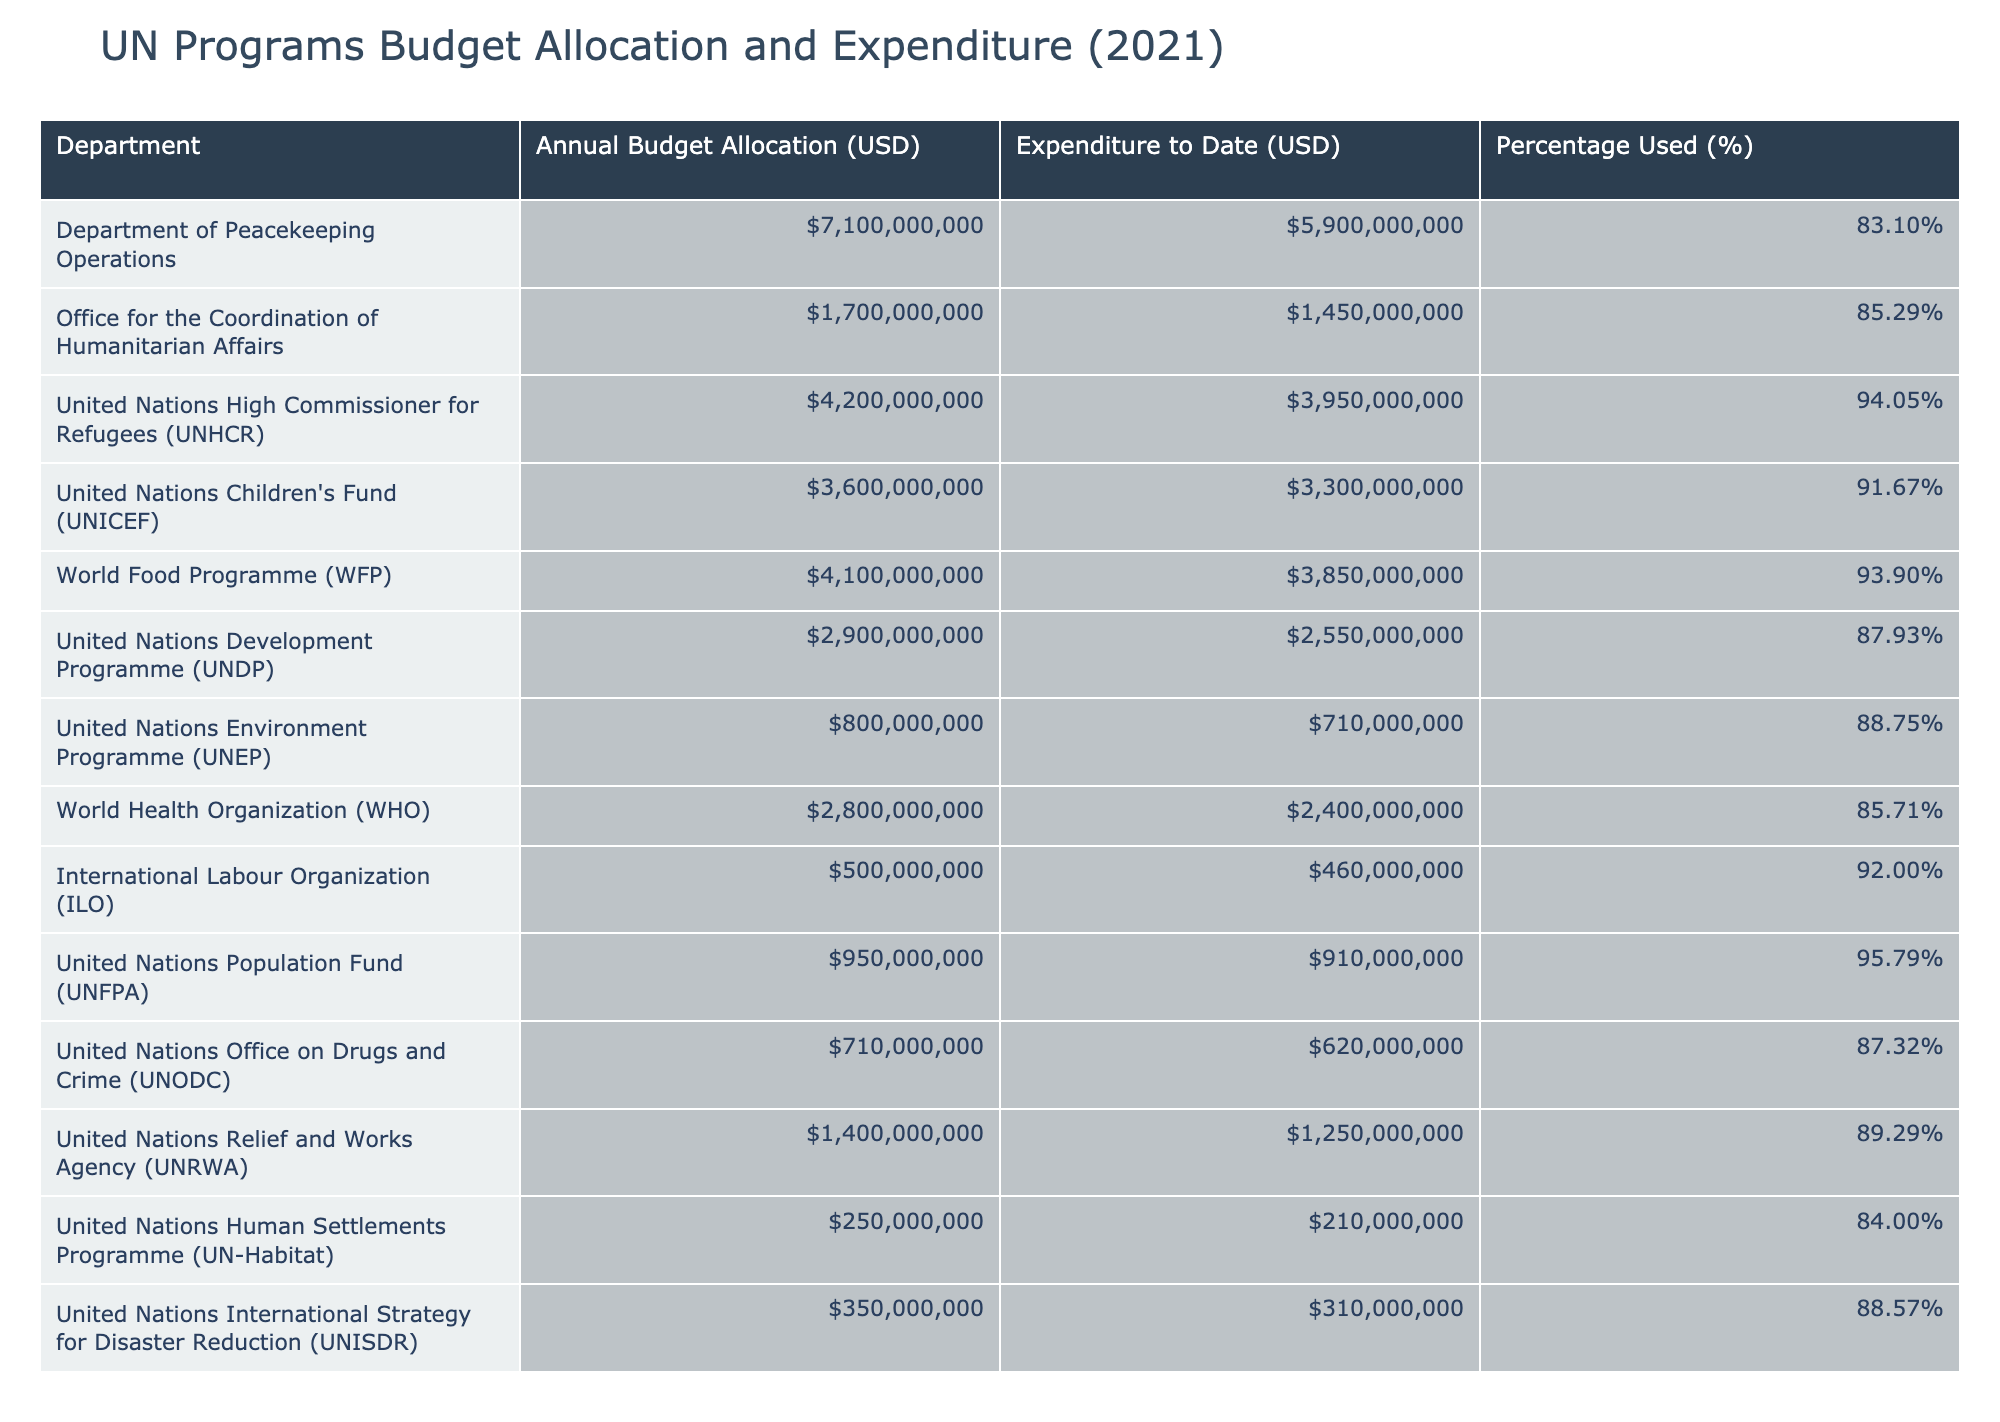What is the annual budget allocation for the United Nations Children's Fund (UNICEF)? The table lists the annual budget allocation for each department, and for UNICEF, it clearly states 3,600,000,000 USD.
Answer: 3,600,000,000 USD What percentage of the budget has been used by the United Nations High Commissioner for Refugees (UNHCR)? The percentage used column for UNHCR indicates that 94.05% of its budget has been utilized to date.
Answer: 94.05% Which department has the highest expenditure to date? By reviewing the expenditure to date for each department, UNHCR shows the highest figure at 3,950,000,000 USD.
Answer: UNHCR Is the expenditure for the World Food Programme (WFP) equal to or greater than the expenditure for the UN Development Programme (UNDP)? The expenditure for WFP is 3,850,000,000 USD, while UNDP is 2,550,000,000 USD. Since 3,850,000,000 is greater than 2,550,000,000, the statement is true.
Answer: Yes What is the total budget allocation for the departments with the percentage used greater than 90%? We identify departments with more than 90% used, which are UNHCR, UNICEF, WFP, and UNFPA. Their total budget allocation is 4,200,000,000 + 3,600,000,000 + 4,100,000,000 + 950,000,000 = 12,850,000,000 USD.
Answer: 12,850,000,000 USD Which department has the least percentage of its budget used? Looking through the percentage used, the Department of Human Settlements (UN-Habitat) shows the lowest percentage at 84.00%.
Answer: UN-Habitat What is the average percentage used across all departments? To find the average, the percentages are summed: 83.10 + 85.29 + 94.05 + 91.67 + 93.90 + 87.93 + 88.75 + 85.71 + 92.00 + 95.79 + 87.32 + 89.29 + 84.00 + 88.57 = 1,196.35. Dividing by 14 (the number of departments), the average percentage used is approximately 85.69%.
Answer: 85.69% Is the combined budget allocation for the Office for the Coordination of Humanitarian Affairs and the International Labour Organization greater than that of the World Health Organization? The combined budget for the Office for the Coordination of Humanitarian Affairs (1,700,000,000 USD) and the International Labour Organization (500,000,000 USD) is 2,200,000,000 USD, while the World Health Organization has a budget of 2,800,000,000 USD. Since 2,200,000,000 is less than 2,800,000,000, the statement is false.
Answer: No How much more budget allocation does the Department of Peacekeeping Operations have compared to the United Nations Office on Drugs and Crime (UNODC)? The budget for the Department of Peacekeeping Operations is 7,100,000,000 USD while UNODC is 710,000,000 USD. The difference is 7,100,000,000 - 710,000,000 = 6,390,000,000 USD.
Answer: 6,390,000,000 USD 